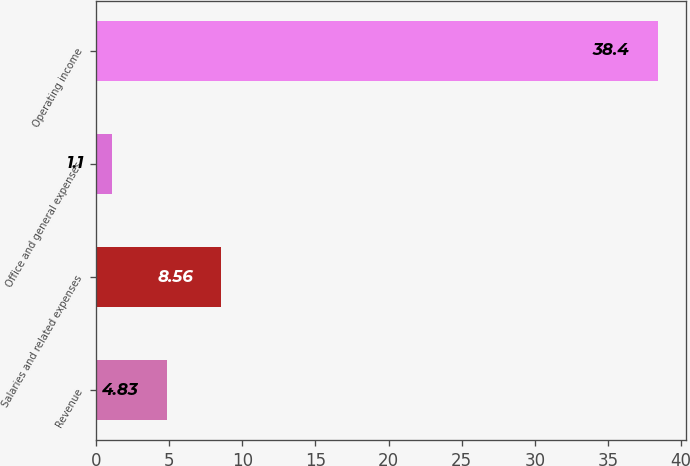Convert chart. <chart><loc_0><loc_0><loc_500><loc_500><bar_chart><fcel>Revenue<fcel>Salaries and related expenses<fcel>Office and general expenses<fcel>Operating income<nl><fcel>4.83<fcel>8.56<fcel>1.1<fcel>38.4<nl></chart> 